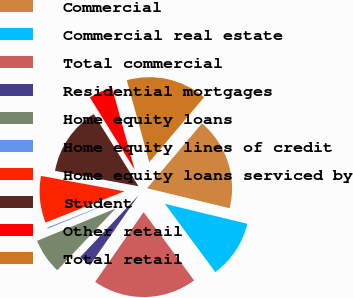Convert chart. <chart><loc_0><loc_0><loc_500><loc_500><pie_chart><fcel>Commercial<fcel>Commercial real estate<fcel>Total commercial<fcel>Residential mortgages<fcel>Home equity loans<fcel>Home equity lines of credit<fcel>Home equity loans serviced by<fcel>Student<fcel>Other retail<fcel>Total retail<nl><fcel>17.62%<fcel>11.09%<fcel>19.79%<fcel>2.38%<fcel>6.74%<fcel>0.21%<fcel>8.91%<fcel>13.26%<fcel>4.56%<fcel>15.44%<nl></chart> 